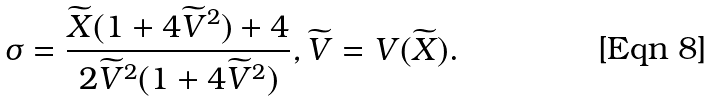Convert formula to latex. <formula><loc_0><loc_0><loc_500><loc_500>\sigma = \frac { \widetilde { X } ( 1 + 4 \widetilde { V } ^ { 2 } ) + 4 } { 2 \widetilde { V } ^ { 2 } ( 1 + 4 \widetilde { V } ^ { 2 } ) } , \widetilde { V } = V ( \widetilde { X } ) .</formula> 